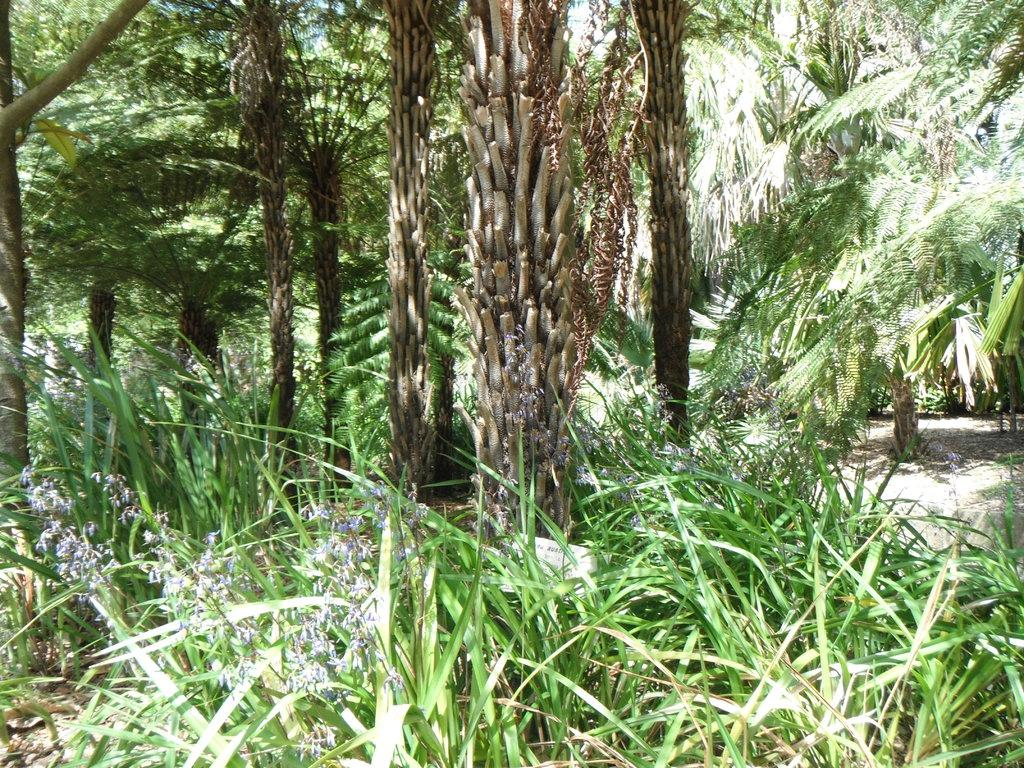What types of vegetation can be seen in the image? There are many plants and trees in the image. Are there any specific features on the plants? Yes, there are flowers on the plants. What is the reason for the kittens to be present in the image? There are no kittens present in the image; it features plants and trees with flowers. 